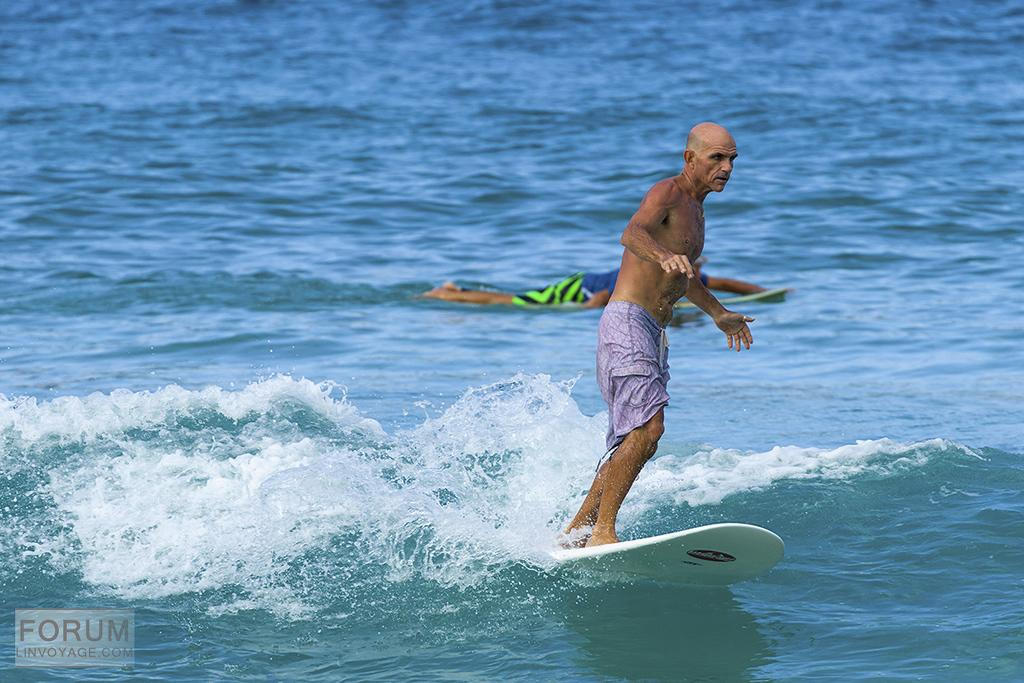What is the person on the skateboard doing in the water? The person is standing on a skateboard in the water. What is the other person doing in the water? The other person is lying on the water. Where is the squirrel playing with toys in the image? There is no squirrel or toys present in the image. What is the person in the water trying to get the attention of? The provided facts do not mention anything about the person in the water trying to get someone's attention. 